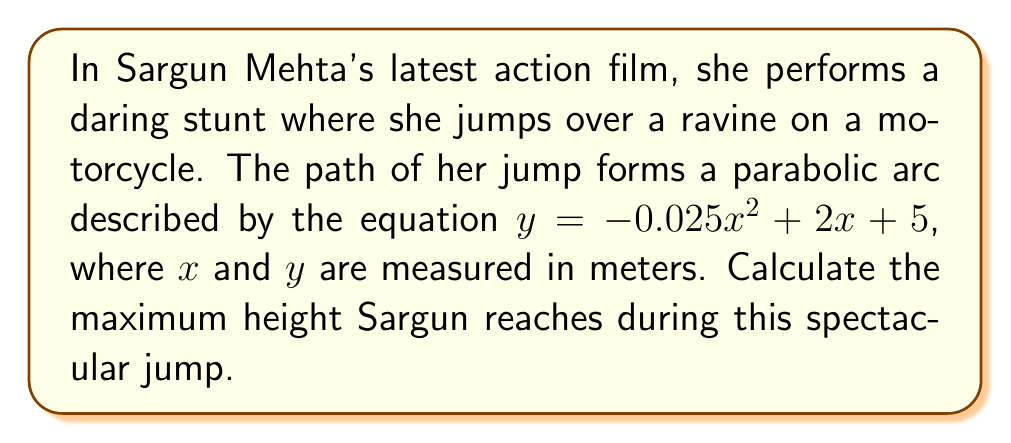Provide a solution to this math problem. To find the maximum height of the parabolic arc, we need to follow these steps:

1) The general form of a quadratic function is $y = ax^2 + bx + c$, where $a$, $b$, and $c$ are constants and $a \neq 0$. In this case:
   $a = -0.025$
   $b = 2$
   $c = 5$

2) For a parabola, the x-coordinate of the vertex represents the point where the maximum (or minimum) occurs. We can find this using the formula:

   $x = -\frac{b}{2a}$

3) Substituting our values:

   $x = -\frac{2}{2(-0.025)} = -\frac{2}{-0.05} = 40$

4) To find the maximum height (y-coordinate), we substitute this x-value back into our original equation:

   $y = -0.025(40)^2 + 2(40) + 5$

5) Simplifying:
   $y = -0.025(1600) + 80 + 5$
   $y = -40 + 80 + 5$
   $y = 45$

Therefore, the maximum height Sargun reaches during her jump is 45 meters.
Answer: 45 meters 